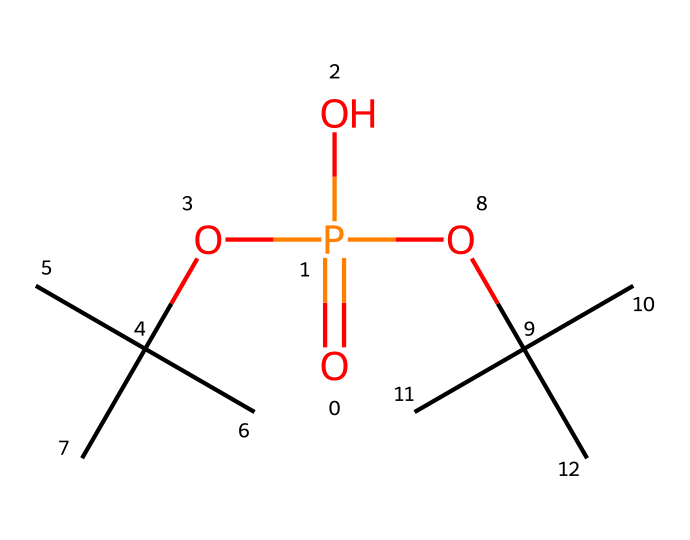what is the oxidation state of phosphorus in this compound? In the given SMILES, phosphorus (P) is bonded to four oxygen atoms. The oxidation state can be calculated by considering that each oxygen typically has an oxidation state of -2. Therefore, the overall charge from four oxygens would be -8, and since there are no other charge contributors, phosphorus must have an oxidation state of +5 to balance this.
Answer: +5 how many carbon atoms are present in this compound? By analyzing the SMILES representation, we can see that there are two isopropyl groups (OC(C)(C)C) and one additional carbon atom from the phosphate group, leading to a total of 6 carbon atoms present in the entire compound. Each isopropyl group contributes three carbon atoms (2 groups), leading to 6 carbon atoms in total.
Answer: 6 what is the type of the phosphorus compound depicted? The structure showcases phosphorus bonded to more than four atoms, which qualifies it as a hypervalent compound. Hypervalent compounds are those that possess an expanded valence shell, allowing for more than eight electrons to be associated with the central atom, in this case, phosphorus.
Answer: hypervalent how many different types of atoms are present in this structure? By examining the SMILES, we can identify the types of atoms present: phosphorus (P), oxygen (O), and carbon (C). This totals three different atom types, as there are no nitrogen, sulfur, or other heteroatoms in the structure.
Answer: 3 is the phosphorus atom in this compound situated in a pyramidal or tetrahedral arrangement? The phosphorus atom in such hypervalent compounds typically exhibits a trigonal bipyramidal geometry due to the presence of five substituents: one double bond with oxygen and four single bonds (considering the two isopropyl groups and two ether linkages). This geometry is characteristic of such structures, indicating it is not simply tetrahedral or pyramidal.
Answer: trigonal bipyramidal what functional groups are evident in this chemical structure? The structure indicates the presence of phosphate functional groups (due to the P=O and P-O bonds), as well as ether linkages formed through the isopropyl groups. Each isopropyl group contributes to the ether formation around the phosphorus center.
Answer: phosphate, ether 